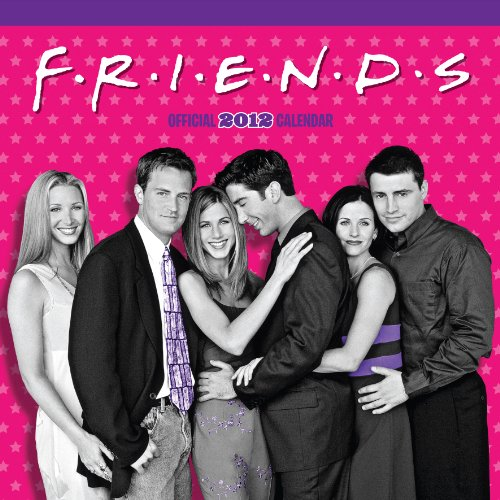Which year's calendar is this? This is a calendar for the year 2012, themed around the TV show 'Friends', featuring images and special dates related to the show. 